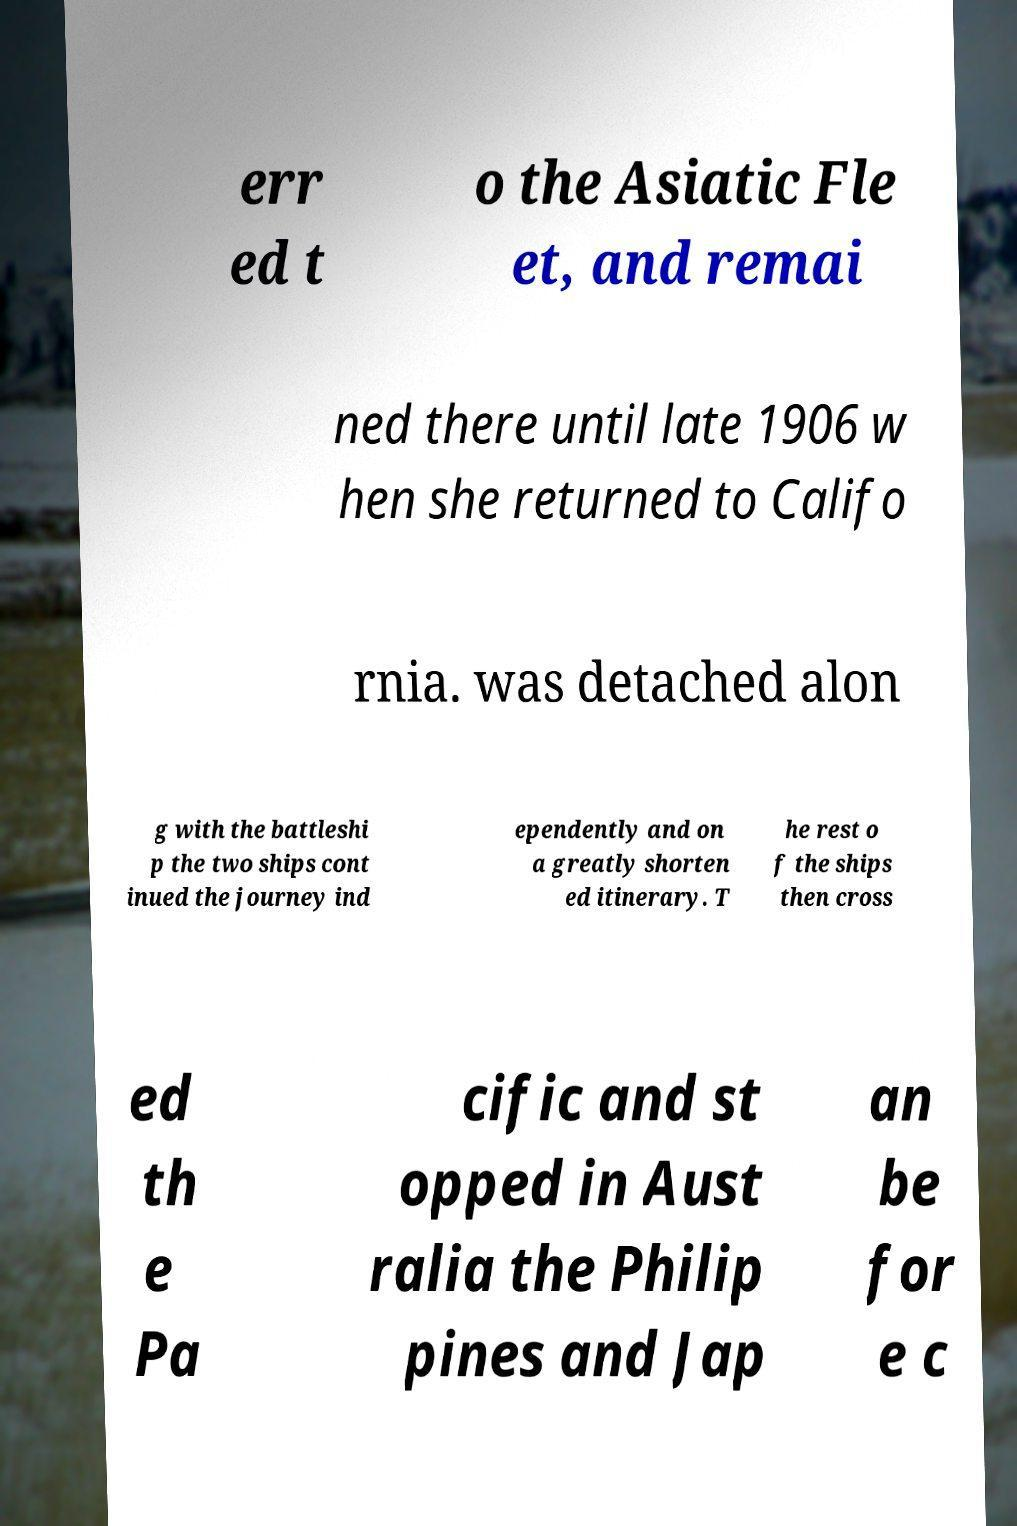For documentation purposes, I need the text within this image transcribed. Could you provide that? err ed t o the Asiatic Fle et, and remai ned there until late 1906 w hen she returned to Califo rnia. was detached alon g with the battleshi p the two ships cont inued the journey ind ependently and on a greatly shorten ed itinerary. T he rest o f the ships then cross ed th e Pa cific and st opped in Aust ralia the Philip pines and Jap an be for e c 